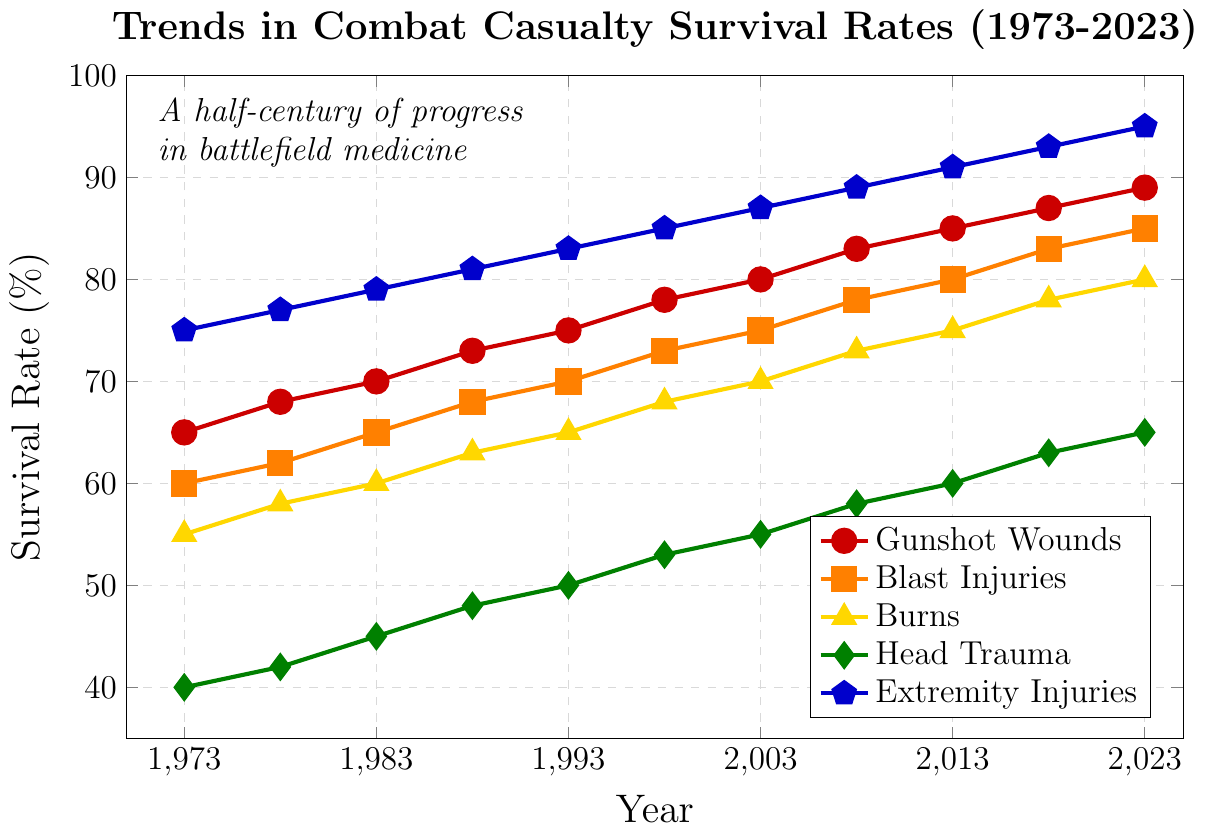What is the survival rate for gunshot wounds in 1973 and 2023? To find the survival rates for gunshot wounds in 1973 and 2023, locate the values for the red line (gunshot wounds) at the corresponding years on the x-axis. The survival rate is 65% in 1973 and 89% in 2023.
Answer: 65% in 1973, 89% in 2023 Which injury type had the highest survival rate in 1993? To determine the highest survival rate in 1993, look at the values for all injury types in that year. Extremity injuries have the highest survival rate at 83%.
Answer: Extremity Injuries How does the survival rate for head trauma in 1983 compare to that in 2023? Compare the values of the green line (head trauma) for the years 1983 and 2023. The survival rate for head trauma was 45% in 1983 and 65% in 2023. Thus, it increased by 20 percentage points.
Answer: 20% increase What's the average survival rate for burns from 1973 to 2023? Add the survival rates for burns (yellow line) for all years from 1973 to 2023 and divide by the number of years. The rates are 55, 58, 60, 63, 65, 68, 70, 73, 75, 78, and 80. The average is (55 + 58 + 60 + 63 + 65 + 68 + 70 + 73 + 75 + 78 + 80)/11 = 67.09%.
Answer: 67.09% Which injury type has shown the greatest improvement in survival rates over the 50-year period? Calculate the increase in survival rates for each injury type from 1973 to 2023: Gunshot Wounds (89-65=24), Blast Injuries (85-60=25), Burns (80-55=25), Head Trauma (65-40=25), Extremity Injuries (95-75=20). The greatest improvements are seen in Blast Injuries, Burns, and Head Trauma, each with a 25 percentage point increase.
Answer: Blast Injuries, Burns, Head Trauma Compare the trend lines for gunshot wounds and extremity injuries: which one shows a steeper increase over the years? Compare the slopes of the red line (gunshot wounds) and the blue line (extremity injuries). The increase from 1973 to 2023 for gunshot wounds is 24 percentage points, while for extremity injuries it is 20 percentage points. Both lines are relatively linear. The gunshot wounds line shows a slightly less steep increase.
Answer: Extremity Injuries What is the difference in the survival rate for blast injuries between 1988 and 2008? Find the survival rates for blast injuries (orange line) in 1988 and 2008. The rates are 68% in 1988 and 78% in 2008. The difference is 78% - 68% = 10%.
Answer: 10% Given the trends, which injury type might surpass 90% survival rate in the next few years, assuming current trends continue? Based on the trends, plot the trajectory of each injury type. Gunshot Wounds are at 89% and rising at a rate that suggests it could surpass 90% soon.
Answer: Gunshot Wounds What year did the survival rate for burns first reach 70%? Look for the first point where the yellow line (burns) reaches or surpasses 70%. This occurs in the year 2003.
Answer: 2003 